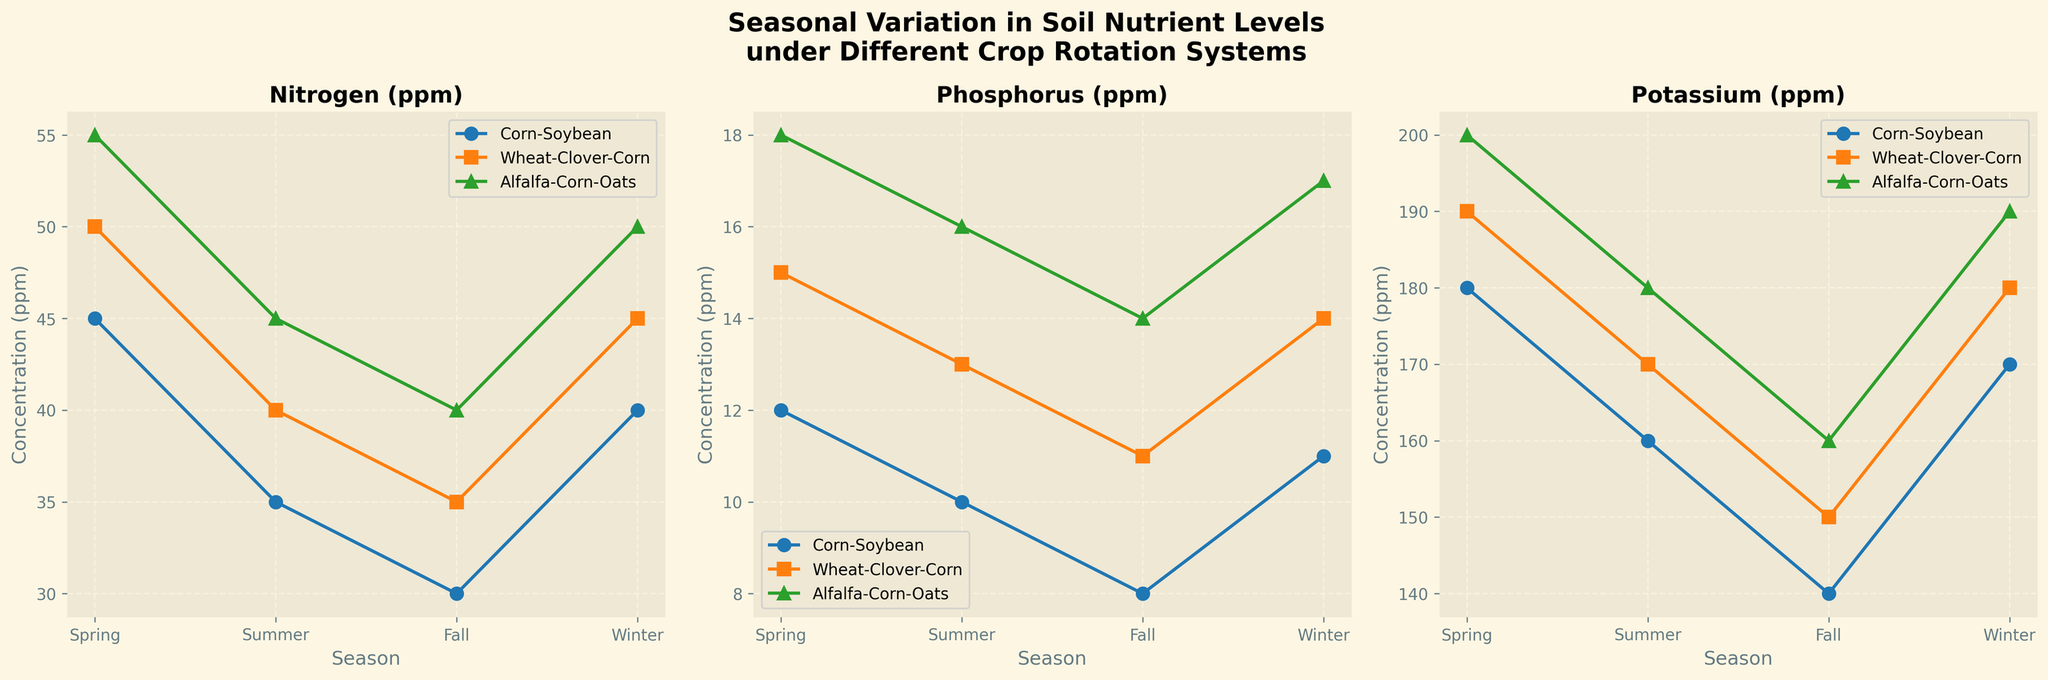What is the title of the figure? The title is displayed at the top of the figure and reads "Seasonal Variation in Soil Nutrient Levels under Different Crop Rotation Systems".
Answer: Seasonal Variation in Soil Nutrient Levels under Different Crop Rotation Systems What seasons are represented along the X-axis? Looking at the X-axis of each subplot, the seasons "Spring", "Summer", "Fall", and "Winter" are shown.
Answer: Spring, Summer, Fall, Winter Which crop rotation system has the highest nitrogen level in spring? In the subplot for nitrogen, the highest point in spring is for the Alfalfa-Corn-Oats rotation system.
Answer: Alfalfa-Corn-Oats What is the average phosphorus level across all seasons for the Wheat-Clover-Corn rotation system? For Wheat-Clover-Corn:
	- Spring: 15 ppm
	- Summer: 13 ppm
	- Fall: 11 ppm
	- Winter: 14 ppm
	Sum these values: 15 + 13 + 11 + 14 = 53
	Average = 53/4 = 13.25 ppm
Answer: 13.25 ppm How does the potassium level change from summer to fall for Corn-Soybean? Referring to the potassium subplot, the Corn-Soybean rotation system shows a decrease from 160 ppm in summer to 140 ppm in fall.
Answer: Decreases Which rotation system has the lowest phosphorus level in fall? In the phosphorus subplot, the Corn-Soybean rotation system has the lowest value in fall with 8 ppm.
Answer: Corn-Soybean How does the nitrogen level for Wheat-Clover-Corn in winter compare to its level in fall? In the nitrogen subplot, the Wheat-Clover-Corn rotation system shows an increase from 35 ppm in fall to 45 ppm in winter.
Answer: Increases Which rotation system has the most consistent potassium levels across the seasons? Reviewing the potassium subplot, Wheat-Clover-Corn shows relatively consistent levels with values close to each other (190, 170, 150, 180 ppm).
Answer: Wheat-Clover-Corn What is the range of nitrogen levels for the Alfalfa-Corn-Oats rotation system? In the nitrogen subplot for Alfalfa-Corn-Oats, the highest value is 55 ppm in spring and the lowest is 40 ppm in fall. Range = 55 - 40 = 15 ppm.
Answer: 15 ppm Is there a season where all three rotation systems show similar phosphorus levels? In the phosphorus subplot for summer, all three systems present values that are quite close: Corn-Soybean (10 ppm), Wheat-Clover-Corn (13 ppm), and Alfalfa-Corn-Oats (16 ppm).
Answer: Summer 